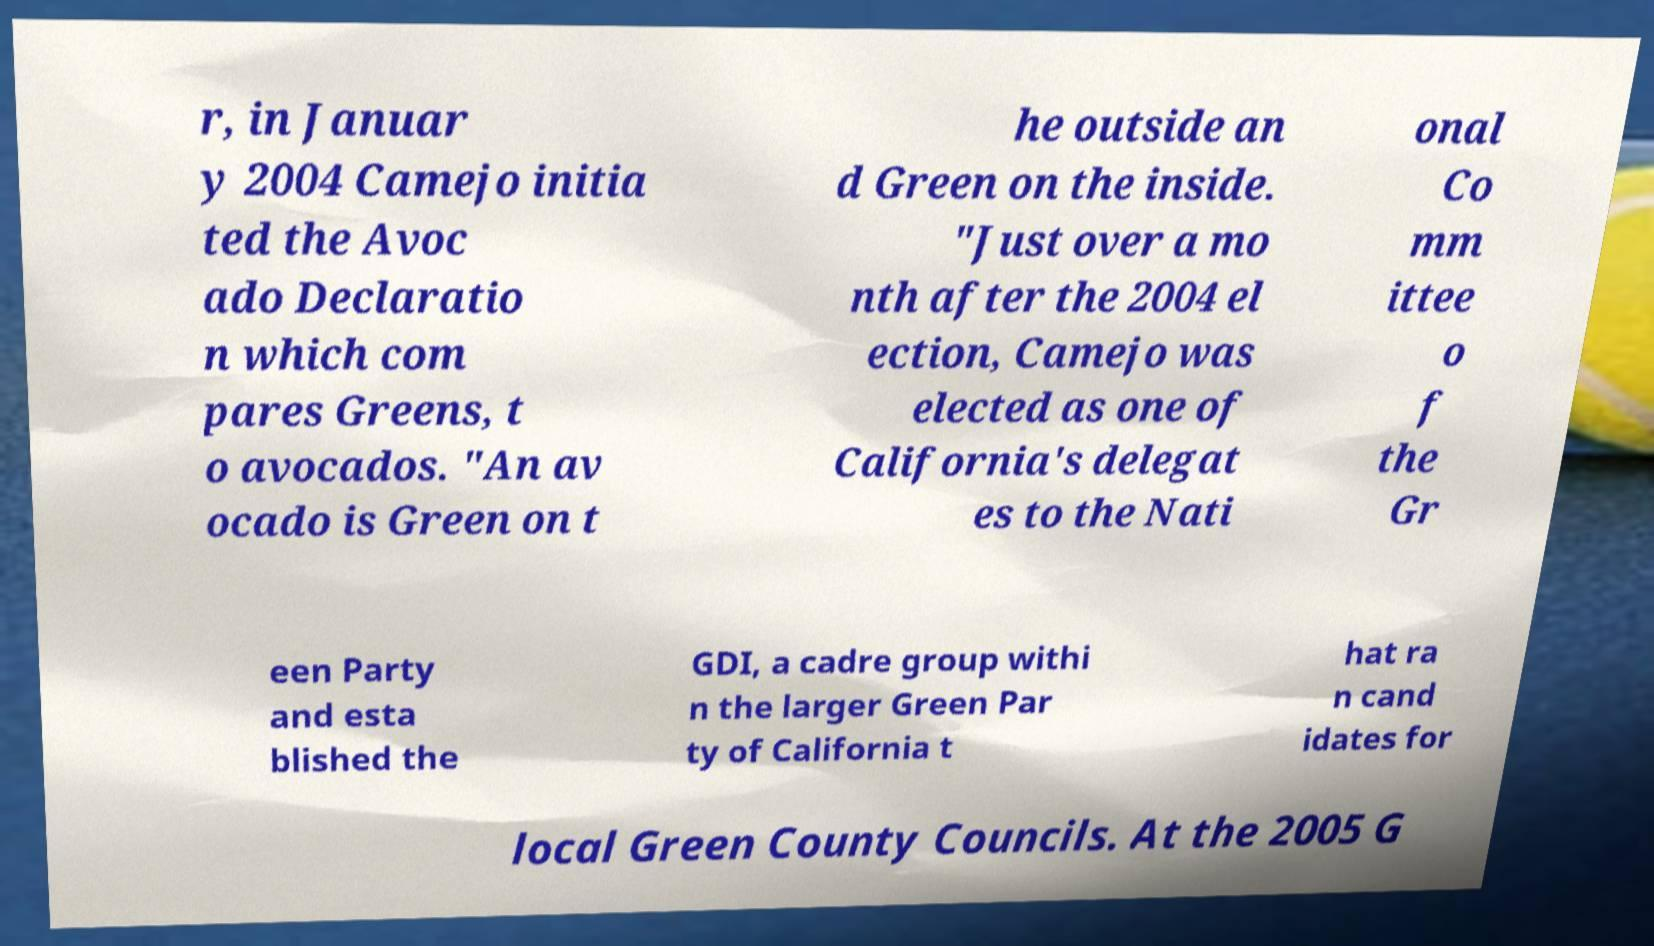For documentation purposes, I need the text within this image transcribed. Could you provide that? r, in Januar y 2004 Camejo initia ted the Avoc ado Declaratio n which com pares Greens, t o avocados. "An av ocado is Green on t he outside an d Green on the inside. "Just over a mo nth after the 2004 el ection, Camejo was elected as one of California's delegat es to the Nati onal Co mm ittee o f the Gr een Party and esta blished the GDI, a cadre group withi n the larger Green Par ty of California t hat ra n cand idates for local Green County Councils. At the 2005 G 